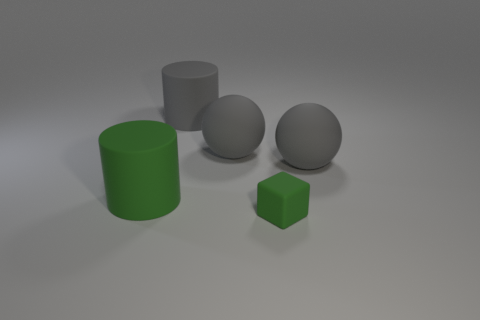Are there any other things that have the same size as the matte cube?
Your answer should be very brief. No. What material is the thing that is the same color as the tiny rubber cube?
Offer a terse response. Rubber. How many large cylinders have the same color as the cube?
Offer a terse response. 1. What size is the thing that is the same color as the block?
Your answer should be very brief. Large. Is the number of large objects on the left side of the block greater than the number of big gray balls?
Offer a terse response. Yes. Do the big thing to the left of the large gray cylinder and the small green matte object have the same shape?
Give a very brief answer. No. What is the green object left of the rubber block made of?
Your answer should be very brief. Rubber. How many gray objects are the same shape as the big green object?
Provide a succinct answer. 1. The big gray cylinder behind the green object that is on the right side of the large green matte cylinder is made of what material?
Offer a very short reply. Rubber. There is another matte thing that is the same color as the small object; what shape is it?
Provide a short and direct response. Cylinder. 